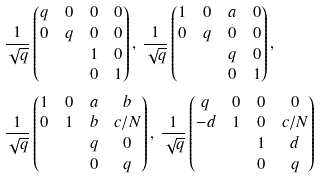Convert formula to latex. <formula><loc_0><loc_0><loc_500><loc_500>& \frac { 1 } { \sqrt { q } } \begin{pmatrix} q & 0 & 0 & 0 \\ 0 & q & 0 & 0 \\ & & 1 & 0 \\ & & 0 & 1 \end{pmatrix} , \, \frac { 1 } { \sqrt { q } } \begin{pmatrix} 1 & 0 & a & 0 \\ 0 & q & 0 & 0 \\ & & q & 0 \\ & & 0 & 1 \end{pmatrix} , \\ & \frac { 1 } { \sqrt { q } } \begin{pmatrix} 1 & 0 & a & b \\ 0 & 1 & b & c / N \\ & & q & 0 \\ & & 0 & q \end{pmatrix} , \, \frac { 1 } { \sqrt { q } } \begin{pmatrix} q & 0 & 0 & 0 \\ - d & 1 & 0 & c / N \\ & & 1 & d \\ & & 0 & q \end{pmatrix}</formula> 